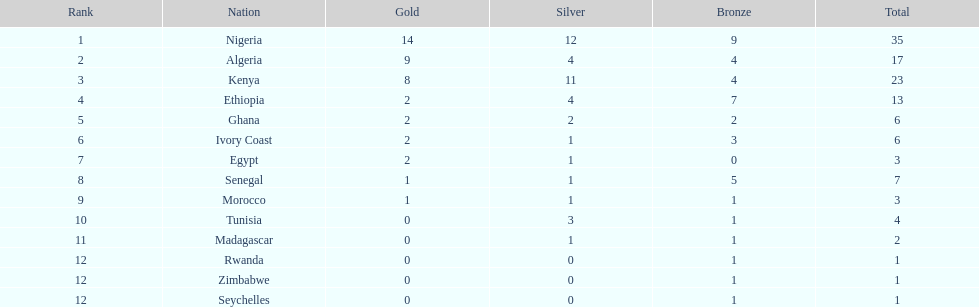How long is the list of countries that won any medals? 14. 